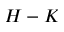<formula> <loc_0><loc_0><loc_500><loc_500>H - K</formula> 